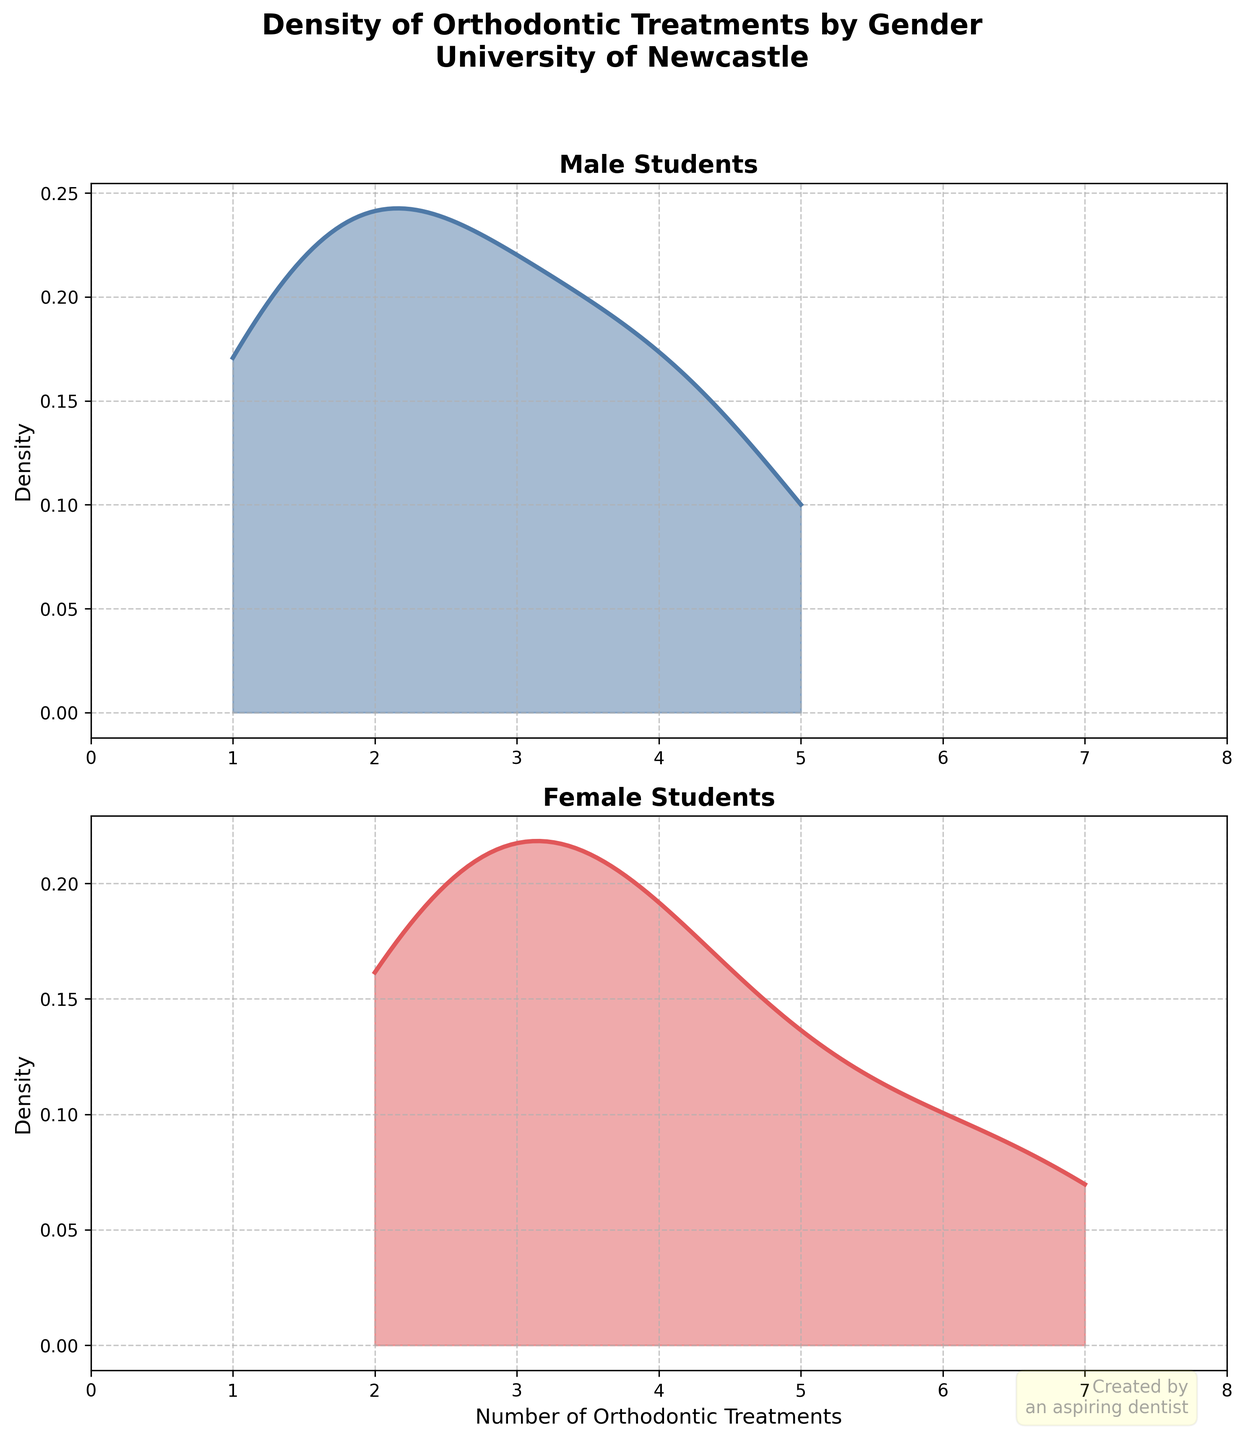What is the title of the figure? The figure prominently features its title at the top. By examining this area, we can identify the title.
Answer: Density of Orthodontic Treatments by Gender University of Newcastle How many subplots are in the figure? The figure layout divides it into multiple sections. Counting these sections reveals the number of subplots.
Answer: 2 What are the colors used in the density plots for male and female students? By referring to the density plots, we can observe the colors used. The male plot predominantly features one color, and the female plot features another.
Answer: Male: Blue, Female: Red What is the maximum number of orthodontic treatments for female students? By considering the density plot for female students and checking the x-axis, the highest number of treatments indicated can be determined.
Answer: 7 What is the approximate peak density value for male students? By examining the y-axis and identifying the highest point of the density curve in the male subplot, we can estimate this value.
Answer: Approximately 0.17 How does the shape of the density curve for female students compare to that of male students? By analyzing the overall shape of both density curves, we can describe the relative position, spread, and features of the curves for each gender.
Answer: The female density curve has a higher and broader peak compared to the male density curve Which gender appears to have a broader distribution of orthodontic treatments? Analyzing the range and spread of both density plots reveals which gender shows more variability in orthodontic treatments.
Answer: Female Do male or female students have a higher frequency of having around 3 orthodontic treatments? By comparing the height of the density curves around the x-value of 3, we can determine which curve is higher, indicating a higher frequency.
Answer: Female What is the range of `Number of Orthodontic Treatments` for male students shown in the density plot? By observing the minimum and maximum points on the x-axis covered by the density curve for male students, the range can be determined.
Answer: 1 to 5 Why is there a watermark in the figure? Observing the bottom of the figure provides an additional visual element that adds unique context to the plotted data presentation.
Answer: It is a creative touch added by the aspiring dentist who created the plot 